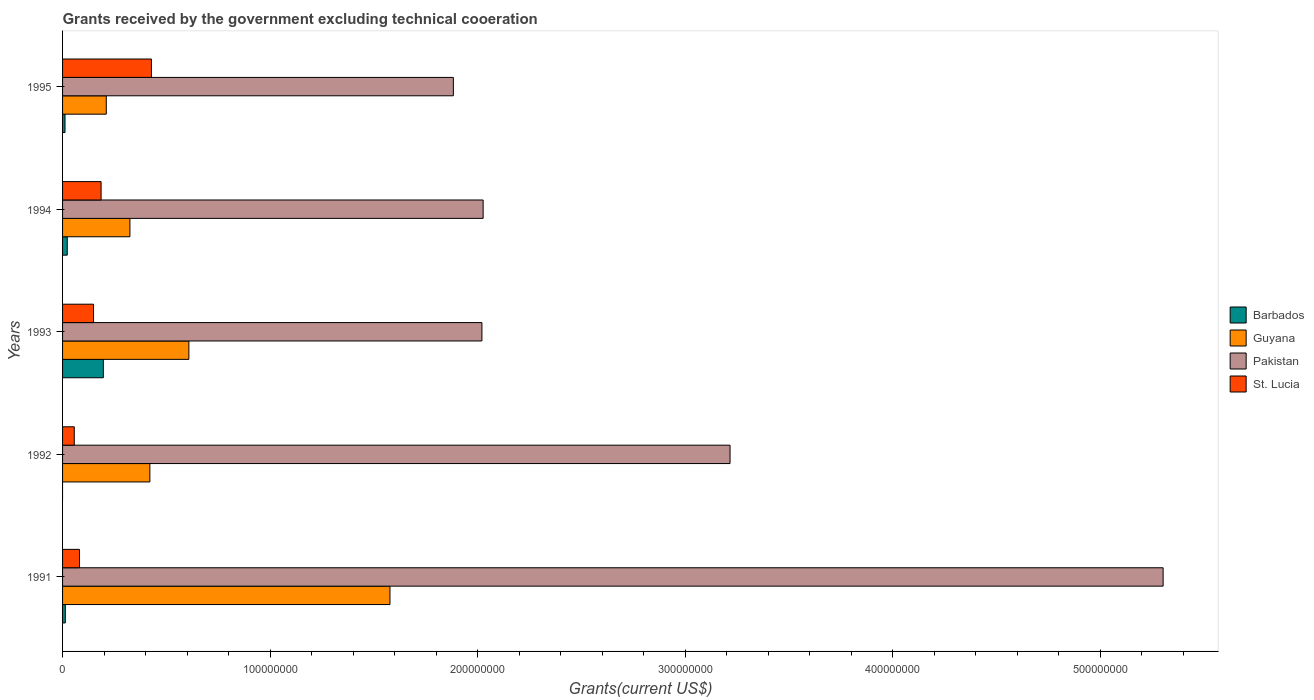How many groups of bars are there?
Your answer should be very brief. 5. Are the number of bars per tick equal to the number of legend labels?
Ensure brevity in your answer.  No. Are the number of bars on each tick of the Y-axis equal?
Offer a terse response. No. How many bars are there on the 2nd tick from the bottom?
Make the answer very short. 3. What is the label of the 2nd group of bars from the top?
Give a very brief answer. 1994. In how many cases, is the number of bars for a given year not equal to the number of legend labels?
Give a very brief answer. 1. What is the total grants received by the government in Guyana in 1993?
Offer a very short reply. 6.09e+07. Across all years, what is the maximum total grants received by the government in St. Lucia?
Your response must be concise. 4.28e+07. Across all years, what is the minimum total grants received by the government in Pakistan?
Make the answer very short. 1.88e+08. What is the total total grants received by the government in St. Lucia in the graph?
Offer a very short reply. 9.01e+07. What is the difference between the total grants received by the government in Pakistan in 1992 and that in 1995?
Keep it short and to the point. 1.33e+08. What is the difference between the total grants received by the government in Barbados in 1994 and the total grants received by the government in Guyana in 1995?
Ensure brevity in your answer.  -1.88e+07. What is the average total grants received by the government in Guyana per year?
Your answer should be compact. 6.28e+07. In the year 1991, what is the difference between the total grants received by the government in Guyana and total grants received by the government in St. Lucia?
Provide a short and direct response. 1.50e+08. What is the ratio of the total grants received by the government in Pakistan in 1993 to that in 1995?
Give a very brief answer. 1.07. What is the difference between the highest and the second highest total grants received by the government in Barbados?
Your answer should be very brief. 1.74e+07. What is the difference between the highest and the lowest total grants received by the government in Pakistan?
Your answer should be compact. 3.42e+08. In how many years, is the total grants received by the government in Guyana greater than the average total grants received by the government in Guyana taken over all years?
Ensure brevity in your answer.  1. How many years are there in the graph?
Offer a very short reply. 5. What is the difference between two consecutive major ticks on the X-axis?
Your answer should be compact. 1.00e+08. Does the graph contain any zero values?
Offer a very short reply. Yes. How many legend labels are there?
Provide a short and direct response. 4. What is the title of the graph?
Your response must be concise. Grants received by the government excluding technical cooeration. What is the label or title of the X-axis?
Provide a succinct answer. Grants(current US$). What is the label or title of the Y-axis?
Offer a very short reply. Years. What is the Grants(current US$) of Barbados in 1991?
Your answer should be compact. 1.33e+06. What is the Grants(current US$) of Guyana in 1991?
Offer a very short reply. 1.58e+08. What is the Grants(current US$) of Pakistan in 1991?
Your answer should be very brief. 5.30e+08. What is the Grants(current US$) of St. Lucia in 1991?
Your response must be concise. 8.17e+06. What is the Grants(current US$) of Barbados in 1992?
Your response must be concise. 0. What is the Grants(current US$) in Guyana in 1992?
Offer a very short reply. 4.21e+07. What is the Grants(current US$) in Pakistan in 1992?
Provide a succinct answer. 3.22e+08. What is the Grants(current US$) of St. Lucia in 1992?
Make the answer very short. 5.64e+06. What is the Grants(current US$) in Barbados in 1993?
Your answer should be compact. 1.96e+07. What is the Grants(current US$) in Guyana in 1993?
Provide a succinct answer. 6.09e+07. What is the Grants(current US$) in Pakistan in 1993?
Your answer should be compact. 2.02e+08. What is the Grants(current US$) of St. Lucia in 1993?
Give a very brief answer. 1.49e+07. What is the Grants(current US$) in Barbados in 1994?
Your response must be concise. 2.26e+06. What is the Grants(current US$) in Guyana in 1994?
Provide a succinct answer. 3.24e+07. What is the Grants(current US$) of Pakistan in 1994?
Keep it short and to the point. 2.03e+08. What is the Grants(current US$) in St. Lucia in 1994?
Make the answer very short. 1.86e+07. What is the Grants(current US$) in Barbados in 1995?
Offer a very short reply. 1.18e+06. What is the Grants(current US$) in Guyana in 1995?
Give a very brief answer. 2.11e+07. What is the Grants(current US$) of Pakistan in 1995?
Offer a terse response. 1.88e+08. What is the Grants(current US$) of St. Lucia in 1995?
Ensure brevity in your answer.  4.28e+07. Across all years, what is the maximum Grants(current US$) of Barbados?
Make the answer very short. 1.96e+07. Across all years, what is the maximum Grants(current US$) of Guyana?
Make the answer very short. 1.58e+08. Across all years, what is the maximum Grants(current US$) of Pakistan?
Your response must be concise. 5.30e+08. Across all years, what is the maximum Grants(current US$) in St. Lucia?
Offer a very short reply. 4.28e+07. Across all years, what is the minimum Grants(current US$) in Guyana?
Provide a short and direct response. 2.11e+07. Across all years, what is the minimum Grants(current US$) of Pakistan?
Offer a terse response. 1.88e+08. Across all years, what is the minimum Grants(current US$) in St. Lucia?
Your answer should be compact. 5.64e+06. What is the total Grants(current US$) of Barbados in the graph?
Offer a terse response. 2.44e+07. What is the total Grants(current US$) in Guyana in the graph?
Your answer should be very brief. 3.14e+08. What is the total Grants(current US$) of Pakistan in the graph?
Offer a terse response. 1.44e+09. What is the total Grants(current US$) of St. Lucia in the graph?
Make the answer very short. 9.01e+07. What is the difference between the Grants(current US$) in Guyana in 1991 and that in 1992?
Ensure brevity in your answer.  1.16e+08. What is the difference between the Grants(current US$) in Pakistan in 1991 and that in 1992?
Your answer should be very brief. 2.09e+08. What is the difference between the Grants(current US$) in St. Lucia in 1991 and that in 1992?
Make the answer very short. 2.53e+06. What is the difference between the Grants(current US$) of Barbados in 1991 and that in 1993?
Offer a very short reply. -1.83e+07. What is the difference between the Grants(current US$) of Guyana in 1991 and that in 1993?
Ensure brevity in your answer.  9.69e+07. What is the difference between the Grants(current US$) of Pakistan in 1991 and that in 1993?
Offer a very short reply. 3.28e+08. What is the difference between the Grants(current US$) in St. Lucia in 1991 and that in 1993?
Provide a succinct answer. -6.75e+06. What is the difference between the Grants(current US$) in Barbados in 1991 and that in 1994?
Provide a succinct answer. -9.30e+05. What is the difference between the Grants(current US$) of Guyana in 1991 and that in 1994?
Ensure brevity in your answer.  1.25e+08. What is the difference between the Grants(current US$) of Pakistan in 1991 and that in 1994?
Provide a succinct answer. 3.28e+08. What is the difference between the Grants(current US$) of St. Lucia in 1991 and that in 1994?
Your answer should be compact. -1.04e+07. What is the difference between the Grants(current US$) of Guyana in 1991 and that in 1995?
Offer a very short reply. 1.37e+08. What is the difference between the Grants(current US$) of Pakistan in 1991 and that in 1995?
Keep it short and to the point. 3.42e+08. What is the difference between the Grants(current US$) in St. Lucia in 1991 and that in 1995?
Make the answer very short. -3.46e+07. What is the difference between the Grants(current US$) of Guyana in 1992 and that in 1993?
Your answer should be compact. -1.88e+07. What is the difference between the Grants(current US$) of Pakistan in 1992 and that in 1993?
Provide a succinct answer. 1.20e+08. What is the difference between the Grants(current US$) of St. Lucia in 1992 and that in 1993?
Offer a very short reply. -9.28e+06. What is the difference between the Grants(current US$) of Guyana in 1992 and that in 1994?
Your answer should be very brief. 9.62e+06. What is the difference between the Grants(current US$) in Pakistan in 1992 and that in 1994?
Offer a terse response. 1.19e+08. What is the difference between the Grants(current US$) in St. Lucia in 1992 and that in 1994?
Your response must be concise. -1.29e+07. What is the difference between the Grants(current US$) in Guyana in 1992 and that in 1995?
Your answer should be compact. 2.10e+07. What is the difference between the Grants(current US$) in Pakistan in 1992 and that in 1995?
Ensure brevity in your answer.  1.33e+08. What is the difference between the Grants(current US$) in St. Lucia in 1992 and that in 1995?
Keep it short and to the point. -3.72e+07. What is the difference between the Grants(current US$) in Barbados in 1993 and that in 1994?
Give a very brief answer. 1.74e+07. What is the difference between the Grants(current US$) in Guyana in 1993 and that in 1994?
Your answer should be very brief. 2.84e+07. What is the difference between the Grants(current US$) of Pakistan in 1993 and that in 1994?
Your answer should be very brief. -5.90e+05. What is the difference between the Grants(current US$) of St. Lucia in 1993 and that in 1994?
Provide a short and direct response. -3.64e+06. What is the difference between the Grants(current US$) in Barbados in 1993 and that in 1995?
Ensure brevity in your answer.  1.85e+07. What is the difference between the Grants(current US$) of Guyana in 1993 and that in 1995?
Offer a very short reply. 3.98e+07. What is the difference between the Grants(current US$) of Pakistan in 1993 and that in 1995?
Offer a terse response. 1.38e+07. What is the difference between the Grants(current US$) of St. Lucia in 1993 and that in 1995?
Your response must be concise. -2.79e+07. What is the difference between the Grants(current US$) in Barbados in 1994 and that in 1995?
Provide a short and direct response. 1.08e+06. What is the difference between the Grants(current US$) of Guyana in 1994 and that in 1995?
Provide a succinct answer. 1.14e+07. What is the difference between the Grants(current US$) of Pakistan in 1994 and that in 1995?
Keep it short and to the point. 1.44e+07. What is the difference between the Grants(current US$) of St. Lucia in 1994 and that in 1995?
Provide a succinct answer. -2.42e+07. What is the difference between the Grants(current US$) of Barbados in 1991 and the Grants(current US$) of Guyana in 1992?
Provide a short and direct response. -4.07e+07. What is the difference between the Grants(current US$) in Barbados in 1991 and the Grants(current US$) in Pakistan in 1992?
Your answer should be compact. -3.20e+08. What is the difference between the Grants(current US$) in Barbados in 1991 and the Grants(current US$) in St. Lucia in 1992?
Offer a very short reply. -4.31e+06. What is the difference between the Grants(current US$) in Guyana in 1991 and the Grants(current US$) in Pakistan in 1992?
Ensure brevity in your answer.  -1.64e+08. What is the difference between the Grants(current US$) in Guyana in 1991 and the Grants(current US$) in St. Lucia in 1992?
Make the answer very short. 1.52e+08. What is the difference between the Grants(current US$) of Pakistan in 1991 and the Grants(current US$) of St. Lucia in 1992?
Your answer should be very brief. 5.25e+08. What is the difference between the Grants(current US$) of Barbados in 1991 and the Grants(current US$) of Guyana in 1993?
Your answer should be very brief. -5.95e+07. What is the difference between the Grants(current US$) of Barbados in 1991 and the Grants(current US$) of Pakistan in 1993?
Ensure brevity in your answer.  -2.01e+08. What is the difference between the Grants(current US$) of Barbados in 1991 and the Grants(current US$) of St. Lucia in 1993?
Provide a short and direct response. -1.36e+07. What is the difference between the Grants(current US$) of Guyana in 1991 and the Grants(current US$) of Pakistan in 1993?
Ensure brevity in your answer.  -4.43e+07. What is the difference between the Grants(current US$) of Guyana in 1991 and the Grants(current US$) of St. Lucia in 1993?
Offer a very short reply. 1.43e+08. What is the difference between the Grants(current US$) of Pakistan in 1991 and the Grants(current US$) of St. Lucia in 1993?
Make the answer very short. 5.15e+08. What is the difference between the Grants(current US$) in Barbados in 1991 and the Grants(current US$) in Guyana in 1994?
Keep it short and to the point. -3.11e+07. What is the difference between the Grants(current US$) of Barbados in 1991 and the Grants(current US$) of Pakistan in 1994?
Offer a terse response. -2.01e+08. What is the difference between the Grants(current US$) of Barbados in 1991 and the Grants(current US$) of St. Lucia in 1994?
Keep it short and to the point. -1.72e+07. What is the difference between the Grants(current US$) of Guyana in 1991 and the Grants(current US$) of Pakistan in 1994?
Give a very brief answer. -4.49e+07. What is the difference between the Grants(current US$) in Guyana in 1991 and the Grants(current US$) in St. Lucia in 1994?
Your response must be concise. 1.39e+08. What is the difference between the Grants(current US$) of Pakistan in 1991 and the Grants(current US$) of St. Lucia in 1994?
Your response must be concise. 5.12e+08. What is the difference between the Grants(current US$) of Barbados in 1991 and the Grants(current US$) of Guyana in 1995?
Provide a succinct answer. -1.97e+07. What is the difference between the Grants(current US$) in Barbados in 1991 and the Grants(current US$) in Pakistan in 1995?
Keep it short and to the point. -1.87e+08. What is the difference between the Grants(current US$) in Barbados in 1991 and the Grants(current US$) in St. Lucia in 1995?
Ensure brevity in your answer.  -4.15e+07. What is the difference between the Grants(current US$) in Guyana in 1991 and the Grants(current US$) in Pakistan in 1995?
Make the answer very short. -3.05e+07. What is the difference between the Grants(current US$) of Guyana in 1991 and the Grants(current US$) of St. Lucia in 1995?
Your answer should be very brief. 1.15e+08. What is the difference between the Grants(current US$) of Pakistan in 1991 and the Grants(current US$) of St. Lucia in 1995?
Provide a short and direct response. 4.87e+08. What is the difference between the Grants(current US$) in Guyana in 1992 and the Grants(current US$) in Pakistan in 1993?
Ensure brevity in your answer.  -1.60e+08. What is the difference between the Grants(current US$) of Guyana in 1992 and the Grants(current US$) of St. Lucia in 1993?
Ensure brevity in your answer.  2.72e+07. What is the difference between the Grants(current US$) of Pakistan in 1992 and the Grants(current US$) of St. Lucia in 1993?
Your answer should be compact. 3.07e+08. What is the difference between the Grants(current US$) of Guyana in 1992 and the Grants(current US$) of Pakistan in 1994?
Provide a succinct answer. -1.61e+08. What is the difference between the Grants(current US$) of Guyana in 1992 and the Grants(current US$) of St. Lucia in 1994?
Give a very brief answer. 2.35e+07. What is the difference between the Grants(current US$) in Pakistan in 1992 and the Grants(current US$) in St. Lucia in 1994?
Keep it short and to the point. 3.03e+08. What is the difference between the Grants(current US$) in Guyana in 1992 and the Grants(current US$) in Pakistan in 1995?
Make the answer very short. -1.46e+08. What is the difference between the Grants(current US$) of Guyana in 1992 and the Grants(current US$) of St. Lucia in 1995?
Your response must be concise. -7.40e+05. What is the difference between the Grants(current US$) of Pakistan in 1992 and the Grants(current US$) of St. Lucia in 1995?
Give a very brief answer. 2.79e+08. What is the difference between the Grants(current US$) of Barbados in 1993 and the Grants(current US$) of Guyana in 1994?
Give a very brief answer. -1.28e+07. What is the difference between the Grants(current US$) of Barbados in 1993 and the Grants(current US$) of Pakistan in 1994?
Your answer should be very brief. -1.83e+08. What is the difference between the Grants(current US$) of Barbados in 1993 and the Grants(current US$) of St. Lucia in 1994?
Your answer should be compact. 1.09e+06. What is the difference between the Grants(current US$) of Guyana in 1993 and the Grants(current US$) of Pakistan in 1994?
Provide a short and direct response. -1.42e+08. What is the difference between the Grants(current US$) of Guyana in 1993 and the Grants(current US$) of St. Lucia in 1994?
Offer a terse response. 4.23e+07. What is the difference between the Grants(current US$) of Pakistan in 1993 and the Grants(current US$) of St. Lucia in 1994?
Provide a succinct answer. 1.83e+08. What is the difference between the Grants(current US$) in Barbados in 1993 and the Grants(current US$) in Guyana in 1995?
Provide a succinct answer. -1.41e+06. What is the difference between the Grants(current US$) in Barbados in 1993 and the Grants(current US$) in Pakistan in 1995?
Make the answer very short. -1.69e+08. What is the difference between the Grants(current US$) of Barbados in 1993 and the Grants(current US$) of St. Lucia in 1995?
Offer a terse response. -2.32e+07. What is the difference between the Grants(current US$) of Guyana in 1993 and the Grants(current US$) of Pakistan in 1995?
Your response must be concise. -1.27e+08. What is the difference between the Grants(current US$) in Guyana in 1993 and the Grants(current US$) in St. Lucia in 1995?
Keep it short and to the point. 1.80e+07. What is the difference between the Grants(current US$) of Pakistan in 1993 and the Grants(current US$) of St. Lucia in 1995?
Offer a very short reply. 1.59e+08. What is the difference between the Grants(current US$) of Barbados in 1994 and the Grants(current US$) of Guyana in 1995?
Provide a short and direct response. -1.88e+07. What is the difference between the Grants(current US$) in Barbados in 1994 and the Grants(current US$) in Pakistan in 1995?
Provide a short and direct response. -1.86e+08. What is the difference between the Grants(current US$) of Barbados in 1994 and the Grants(current US$) of St. Lucia in 1995?
Your answer should be very brief. -4.06e+07. What is the difference between the Grants(current US$) of Guyana in 1994 and the Grants(current US$) of Pakistan in 1995?
Your answer should be compact. -1.56e+08. What is the difference between the Grants(current US$) of Guyana in 1994 and the Grants(current US$) of St. Lucia in 1995?
Keep it short and to the point. -1.04e+07. What is the difference between the Grants(current US$) of Pakistan in 1994 and the Grants(current US$) of St. Lucia in 1995?
Ensure brevity in your answer.  1.60e+08. What is the average Grants(current US$) of Barbados per year?
Your response must be concise. 4.88e+06. What is the average Grants(current US$) of Guyana per year?
Make the answer very short. 6.28e+07. What is the average Grants(current US$) in Pakistan per year?
Offer a terse response. 2.89e+08. What is the average Grants(current US$) in St. Lucia per year?
Make the answer very short. 1.80e+07. In the year 1991, what is the difference between the Grants(current US$) in Barbados and Grants(current US$) in Guyana?
Give a very brief answer. -1.56e+08. In the year 1991, what is the difference between the Grants(current US$) in Barbados and Grants(current US$) in Pakistan?
Keep it short and to the point. -5.29e+08. In the year 1991, what is the difference between the Grants(current US$) of Barbados and Grants(current US$) of St. Lucia?
Give a very brief answer. -6.84e+06. In the year 1991, what is the difference between the Grants(current US$) of Guyana and Grants(current US$) of Pakistan?
Give a very brief answer. -3.73e+08. In the year 1991, what is the difference between the Grants(current US$) in Guyana and Grants(current US$) in St. Lucia?
Give a very brief answer. 1.50e+08. In the year 1991, what is the difference between the Grants(current US$) of Pakistan and Grants(current US$) of St. Lucia?
Your response must be concise. 5.22e+08. In the year 1992, what is the difference between the Grants(current US$) of Guyana and Grants(current US$) of Pakistan?
Give a very brief answer. -2.80e+08. In the year 1992, what is the difference between the Grants(current US$) of Guyana and Grants(current US$) of St. Lucia?
Offer a terse response. 3.64e+07. In the year 1992, what is the difference between the Grants(current US$) of Pakistan and Grants(current US$) of St. Lucia?
Ensure brevity in your answer.  3.16e+08. In the year 1993, what is the difference between the Grants(current US$) in Barbados and Grants(current US$) in Guyana?
Your answer should be very brief. -4.12e+07. In the year 1993, what is the difference between the Grants(current US$) of Barbados and Grants(current US$) of Pakistan?
Ensure brevity in your answer.  -1.82e+08. In the year 1993, what is the difference between the Grants(current US$) in Barbados and Grants(current US$) in St. Lucia?
Your response must be concise. 4.73e+06. In the year 1993, what is the difference between the Grants(current US$) in Guyana and Grants(current US$) in Pakistan?
Offer a very short reply. -1.41e+08. In the year 1993, what is the difference between the Grants(current US$) in Guyana and Grants(current US$) in St. Lucia?
Your response must be concise. 4.59e+07. In the year 1993, what is the difference between the Grants(current US$) in Pakistan and Grants(current US$) in St. Lucia?
Provide a succinct answer. 1.87e+08. In the year 1994, what is the difference between the Grants(current US$) of Barbados and Grants(current US$) of Guyana?
Ensure brevity in your answer.  -3.02e+07. In the year 1994, what is the difference between the Grants(current US$) of Barbados and Grants(current US$) of Pakistan?
Provide a short and direct response. -2.00e+08. In the year 1994, what is the difference between the Grants(current US$) in Barbados and Grants(current US$) in St. Lucia?
Offer a terse response. -1.63e+07. In the year 1994, what is the difference between the Grants(current US$) of Guyana and Grants(current US$) of Pakistan?
Give a very brief answer. -1.70e+08. In the year 1994, what is the difference between the Grants(current US$) of Guyana and Grants(current US$) of St. Lucia?
Your answer should be very brief. 1.39e+07. In the year 1994, what is the difference between the Grants(current US$) in Pakistan and Grants(current US$) in St. Lucia?
Provide a succinct answer. 1.84e+08. In the year 1995, what is the difference between the Grants(current US$) in Barbados and Grants(current US$) in Guyana?
Your answer should be compact. -1.99e+07. In the year 1995, what is the difference between the Grants(current US$) in Barbados and Grants(current US$) in Pakistan?
Keep it short and to the point. -1.87e+08. In the year 1995, what is the difference between the Grants(current US$) of Barbados and Grants(current US$) of St. Lucia?
Offer a very short reply. -4.16e+07. In the year 1995, what is the difference between the Grants(current US$) in Guyana and Grants(current US$) in Pakistan?
Keep it short and to the point. -1.67e+08. In the year 1995, what is the difference between the Grants(current US$) of Guyana and Grants(current US$) of St. Lucia?
Provide a succinct answer. -2.18e+07. In the year 1995, what is the difference between the Grants(current US$) in Pakistan and Grants(current US$) in St. Lucia?
Your answer should be very brief. 1.45e+08. What is the ratio of the Grants(current US$) in Guyana in 1991 to that in 1992?
Offer a very short reply. 3.75. What is the ratio of the Grants(current US$) in Pakistan in 1991 to that in 1992?
Ensure brevity in your answer.  1.65. What is the ratio of the Grants(current US$) of St. Lucia in 1991 to that in 1992?
Keep it short and to the point. 1.45. What is the ratio of the Grants(current US$) in Barbados in 1991 to that in 1993?
Your answer should be compact. 0.07. What is the ratio of the Grants(current US$) in Guyana in 1991 to that in 1993?
Offer a very short reply. 2.59. What is the ratio of the Grants(current US$) in Pakistan in 1991 to that in 1993?
Provide a short and direct response. 2.62. What is the ratio of the Grants(current US$) in St. Lucia in 1991 to that in 1993?
Keep it short and to the point. 0.55. What is the ratio of the Grants(current US$) of Barbados in 1991 to that in 1994?
Your answer should be very brief. 0.59. What is the ratio of the Grants(current US$) in Guyana in 1991 to that in 1994?
Your response must be concise. 4.86. What is the ratio of the Grants(current US$) of Pakistan in 1991 to that in 1994?
Offer a terse response. 2.62. What is the ratio of the Grants(current US$) of St. Lucia in 1991 to that in 1994?
Give a very brief answer. 0.44. What is the ratio of the Grants(current US$) of Barbados in 1991 to that in 1995?
Ensure brevity in your answer.  1.13. What is the ratio of the Grants(current US$) of Guyana in 1991 to that in 1995?
Provide a short and direct response. 7.49. What is the ratio of the Grants(current US$) of Pakistan in 1991 to that in 1995?
Keep it short and to the point. 2.82. What is the ratio of the Grants(current US$) in St. Lucia in 1991 to that in 1995?
Offer a very short reply. 0.19. What is the ratio of the Grants(current US$) of Guyana in 1992 to that in 1993?
Your answer should be very brief. 0.69. What is the ratio of the Grants(current US$) in Pakistan in 1992 to that in 1993?
Give a very brief answer. 1.59. What is the ratio of the Grants(current US$) of St. Lucia in 1992 to that in 1993?
Ensure brevity in your answer.  0.38. What is the ratio of the Grants(current US$) of Guyana in 1992 to that in 1994?
Your answer should be compact. 1.3. What is the ratio of the Grants(current US$) in Pakistan in 1992 to that in 1994?
Provide a short and direct response. 1.59. What is the ratio of the Grants(current US$) of St. Lucia in 1992 to that in 1994?
Your response must be concise. 0.3. What is the ratio of the Grants(current US$) of Guyana in 1992 to that in 1995?
Provide a succinct answer. 2. What is the ratio of the Grants(current US$) in Pakistan in 1992 to that in 1995?
Your answer should be compact. 1.71. What is the ratio of the Grants(current US$) in St. Lucia in 1992 to that in 1995?
Your response must be concise. 0.13. What is the ratio of the Grants(current US$) in Barbados in 1993 to that in 1994?
Your answer should be very brief. 8.69. What is the ratio of the Grants(current US$) in Guyana in 1993 to that in 1994?
Provide a succinct answer. 1.88. What is the ratio of the Grants(current US$) of Pakistan in 1993 to that in 1994?
Give a very brief answer. 1. What is the ratio of the Grants(current US$) in St. Lucia in 1993 to that in 1994?
Make the answer very short. 0.8. What is the ratio of the Grants(current US$) of Barbados in 1993 to that in 1995?
Provide a succinct answer. 16.65. What is the ratio of the Grants(current US$) in Guyana in 1993 to that in 1995?
Offer a very short reply. 2.89. What is the ratio of the Grants(current US$) of Pakistan in 1993 to that in 1995?
Offer a very short reply. 1.07. What is the ratio of the Grants(current US$) in St. Lucia in 1993 to that in 1995?
Your answer should be compact. 0.35. What is the ratio of the Grants(current US$) of Barbados in 1994 to that in 1995?
Your answer should be compact. 1.92. What is the ratio of the Grants(current US$) in Guyana in 1994 to that in 1995?
Offer a terse response. 1.54. What is the ratio of the Grants(current US$) in Pakistan in 1994 to that in 1995?
Your answer should be compact. 1.08. What is the ratio of the Grants(current US$) of St. Lucia in 1994 to that in 1995?
Your answer should be very brief. 0.43. What is the difference between the highest and the second highest Grants(current US$) in Barbados?
Give a very brief answer. 1.74e+07. What is the difference between the highest and the second highest Grants(current US$) of Guyana?
Your response must be concise. 9.69e+07. What is the difference between the highest and the second highest Grants(current US$) in Pakistan?
Make the answer very short. 2.09e+08. What is the difference between the highest and the second highest Grants(current US$) in St. Lucia?
Provide a succinct answer. 2.42e+07. What is the difference between the highest and the lowest Grants(current US$) in Barbados?
Give a very brief answer. 1.96e+07. What is the difference between the highest and the lowest Grants(current US$) of Guyana?
Keep it short and to the point. 1.37e+08. What is the difference between the highest and the lowest Grants(current US$) in Pakistan?
Your answer should be compact. 3.42e+08. What is the difference between the highest and the lowest Grants(current US$) of St. Lucia?
Offer a terse response. 3.72e+07. 